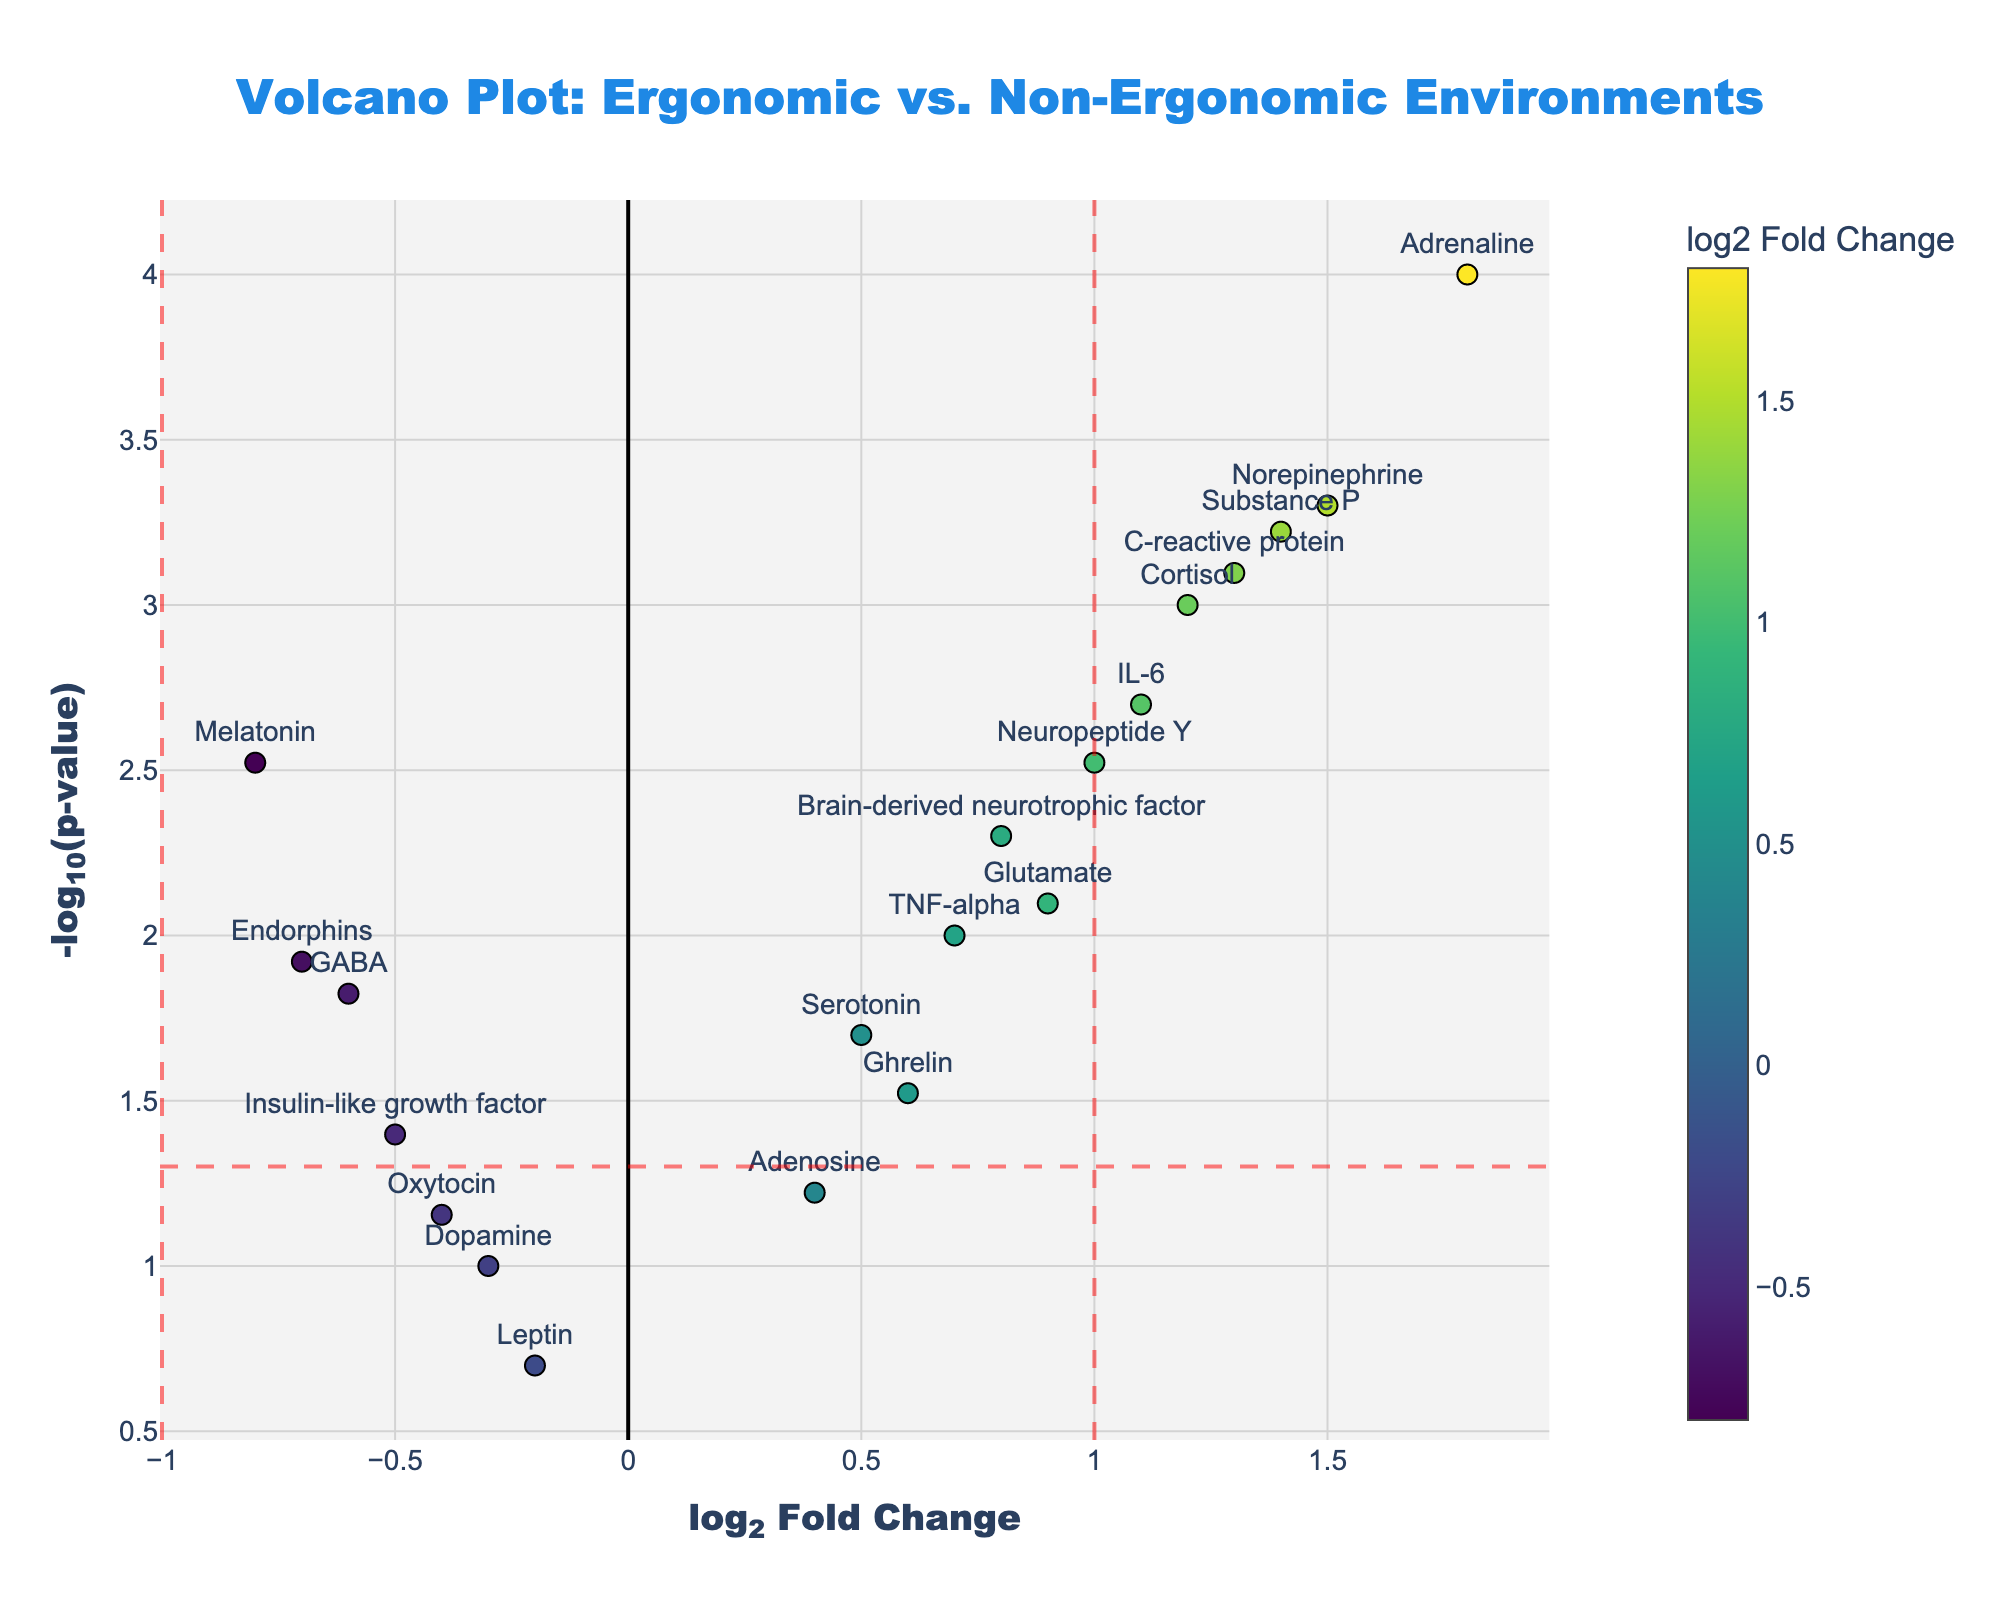What is the title of the plot? The title of the plot is located at the top center of the figure and is typically the largest text displayed in the visualization.
Answer: Volcano Plot: Ergonomic vs. Non-Ergonomic Environments What are the x and y-axis labels? The x-axis and y-axis labels are typically located below and to the left of the respective axes. In this plot, the x-axis label is "log2 Fold Change," and the y-axis label is "-log10(p-value)."
Answer: log2 Fold Change, -log10(p-value) Which gene has the highest -log10(p-value) and what is its log2FoldChange? By looking at the topmost point on the y-axis, you can identify the gene with the highest -log10(p-value). This gene should also be labeled directly on the plot.
Answer: Adrenaline, 1.8 How many genes have a log2FoldChange greater than 1? To count how many genes have a log2FoldChange greater than 1, locate all data points to the right of the vertical red line at x=1. Count these points and their labels.
Answer: 5 Which gene has the lowest p-value and what does it indicate? The gene with the lowest p-value can be found at the highest point on the y-axis since -log10(p-value) will be the highest for the smallest p-value. This gene is labeled on the plot.
Answer: Adrenaline, indicating its statistically significant difference between the two conditions How many genes have a p-value less than 0.05? Identify the genes represented by points above the horizontal red dash line at y=-log10(0.05). Count these points/labels.
Answer: 13 Which two genes have the most similar log2FoldChange values, and what are those values? Look for data points clustered closely together on the x-axis. Determine which two points have the closest horizontal positions.
Answer: Insulin-like growth factor and Endorphins, both approximately -0.5 and -0.7 respectively What is the relationship between Cortisol and Melatonin in terms of fold change? Find Cortisol and Melatonin on the plot and compare their positions on the x-axis. Cortisol is on the positive side, while Melatonin is on the negative side.
Answer: Cortisol has a higher log2FoldChange (1.2) compared to Melatonin (-0.8) Are there any stress-related biomarkers with a log2FoldChange value exactly equal to 1? Examine the data points to see which ones are positioned exactly at log2FoldChange = 1 on the x-axis.
Answer: No gene has exactly log2FoldChange = 1, but Neuropeptide Y is close with log2FoldChange = 1.0 